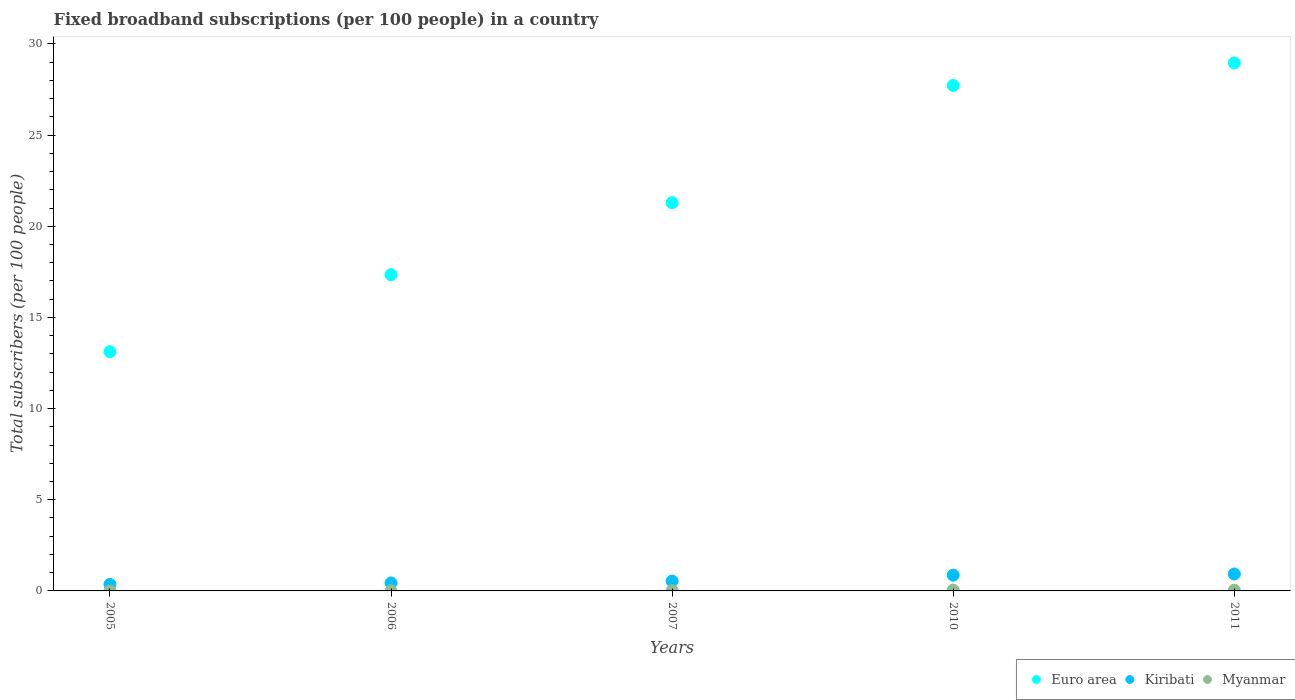How many different coloured dotlines are there?
Offer a terse response. 3. Is the number of dotlines equal to the number of legend labels?
Provide a succinct answer. Yes. What is the number of broadband subscriptions in Euro area in 2010?
Ensure brevity in your answer.  27.72. Across all years, what is the maximum number of broadband subscriptions in Kiribati?
Offer a very short reply. 0.93. Across all years, what is the minimum number of broadband subscriptions in Euro area?
Your answer should be very brief. 13.12. In which year was the number of broadband subscriptions in Kiribati minimum?
Keep it short and to the point. 2005. What is the total number of broadband subscriptions in Euro area in the graph?
Make the answer very short. 108.43. What is the difference between the number of broadband subscriptions in Myanmar in 2005 and that in 2006?
Your response must be concise. -0.01. What is the difference between the number of broadband subscriptions in Kiribati in 2006 and the number of broadband subscriptions in Euro area in 2005?
Provide a succinct answer. -12.68. What is the average number of broadband subscriptions in Myanmar per year?
Keep it short and to the point. 0.02. In the year 2007, what is the difference between the number of broadband subscriptions in Kiribati and number of broadband subscriptions in Euro area?
Your answer should be compact. -20.75. What is the ratio of the number of broadband subscriptions in Euro area in 2005 to that in 2007?
Make the answer very short. 0.62. Is the difference between the number of broadband subscriptions in Kiribati in 2006 and 2011 greater than the difference between the number of broadband subscriptions in Euro area in 2006 and 2011?
Your response must be concise. Yes. What is the difference between the highest and the second highest number of broadband subscriptions in Kiribati?
Make the answer very short. 0.06. What is the difference between the highest and the lowest number of broadband subscriptions in Myanmar?
Provide a short and direct response. 0.04. In how many years, is the number of broadband subscriptions in Myanmar greater than the average number of broadband subscriptions in Myanmar taken over all years?
Provide a succinct answer. 2. Is it the case that in every year, the sum of the number of broadband subscriptions in Myanmar and number of broadband subscriptions in Kiribati  is greater than the number of broadband subscriptions in Euro area?
Your response must be concise. No. Does the number of broadband subscriptions in Myanmar monotonically increase over the years?
Your response must be concise. No. Is the number of broadband subscriptions in Myanmar strictly less than the number of broadband subscriptions in Euro area over the years?
Keep it short and to the point. Yes. How many years are there in the graph?
Ensure brevity in your answer.  5. Does the graph contain any zero values?
Your answer should be compact. No. Where does the legend appear in the graph?
Offer a terse response. Bottom right. How many legend labels are there?
Provide a short and direct response. 3. How are the legend labels stacked?
Your answer should be compact. Horizontal. What is the title of the graph?
Your answer should be compact. Fixed broadband subscriptions (per 100 people) in a country. What is the label or title of the X-axis?
Your answer should be very brief. Years. What is the label or title of the Y-axis?
Give a very brief answer. Total subscribers (per 100 people). What is the Total subscribers (per 100 people) of Euro area in 2005?
Make the answer very short. 13.12. What is the Total subscribers (per 100 people) in Kiribati in 2005?
Provide a short and direct response. 0.36. What is the Total subscribers (per 100 people) of Myanmar in 2005?
Provide a succinct answer. 0. What is the Total subscribers (per 100 people) of Euro area in 2006?
Provide a succinct answer. 17.34. What is the Total subscribers (per 100 people) in Kiribati in 2006?
Make the answer very short. 0.44. What is the Total subscribers (per 100 people) in Myanmar in 2006?
Give a very brief answer. 0.01. What is the Total subscribers (per 100 people) of Euro area in 2007?
Keep it short and to the point. 21.29. What is the Total subscribers (per 100 people) of Kiribati in 2007?
Your answer should be very brief. 0.54. What is the Total subscribers (per 100 people) of Myanmar in 2007?
Give a very brief answer. 0.01. What is the Total subscribers (per 100 people) of Euro area in 2010?
Your answer should be compact. 27.72. What is the Total subscribers (per 100 people) in Kiribati in 2010?
Provide a succinct answer. 0.87. What is the Total subscribers (per 100 people) of Myanmar in 2010?
Offer a terse response. 0.04. What is the Total subscribers (per 100 people) in Euro area in 2011?
Offer a very short reply. 28.96. What is the Total subscribers (per 100 people) of Kiribati in 2011?
Provide a succinct answer. 0.93. What is the Total subscribers (per 100 people) in Myanmar in 2011?
Your answer should be very brief. 0.04. Across all years, what is the maximum Total subscribers (per 100 people) in Euro area?
Make the answer very short. 28.96. Across all years, what is the maximum Total subscribers (per 100 people) in Kiribati?
Keep it short and to the point. 0.93. Across all years, what is the maximum Total subscribers (per 100 people) in Myanmar?
Keep it short and to the point. 0.04. Across all years, what is the minimum Total subscribers (per 100 people) of Euro area?
Make the answer very short. 13.12. Across all years, what is the minimum Total subscribers (per 100 people) of Kiribati?
Keep it short and to the point. 0.36. Across all years, what is the minimum Total subscribers (per 100 people) in Myanmar?
Your answer should be very brief. 0. What is the total Total subscribers (per 100 people) of Euro area in the graph?
Offer a terse response. 108.43. What is the total Total subscribers (per 100 people) of Kiribati in the graph?
Give a very brief answer. 3.13. What is the total Total subscribers (per 100 people) of Myanmar in the graph?
Your response must be concise. 0.11. What is the difference between the Total subscribers (per 100 people) in Euro area in 2005 and that in 2006?
Provide a succinct answer. -4.22. What is the difference between the Total subscribers (per 100 people) of Kiribati in 2005 and that in 2006?
Ensure brevity in your answer.  -0.08. What is the difference between the Total subscribers (per 100 people) of Myanmar in 2005 and that in 2006?
Offer a terse response. -0.01. What is the difference between the Total subscribers (per 100 people) in Euro area in 2005 and that in 2007?
Offer a very short reply. -8.17. What is the difference between the Total subscribers (per 100 people) in Kiribati in 2005 and that in 2007?
Offer a very short reply. -0.18. What is the difference between the Total subscribers (per 100 people) of Myanmar in 2005 and that in 2007?
Keep it short and to the point. -0.01. What is the difference between the Total subscribers (per 100 people) in Euro area in 2005 and that in 2010?
Your answer should be very brief. -14.6. What is the difference between the Total subscribers (per 100 people) of Kiribati in 2005 and that in 2010?
Your response must be concise. -0.51. What is the difference between the Total subscribers (per 100 people) in Myanmar in 2005 and that in 2010?
Your answer should be compact. -0.04. What is the difference between the Total subscribers (per 100 people) of Euro area in 2005 and that in 2011?
Make the answer very short. -15.84. What is the difference between the Total subscribers (per 100 people) in Kiribati in 2005 and that in 2011?
Keep it short and to the point. -0.57. What is the difference between the Total subscribers (per 100 people) in Myanmar in 2005 and that in 2011?
Offer a very short reply. -0.04. What is the difference between the Total subscribers (per 100 people) in Euro area in 2006 and that in 2007?
Give a very brief answer. -3.95. What is the difference between the Total subscribers (per 100 people) in Kiribati in 2006 and that in 2007?
Your answer should be compact. -0.1. What is the difference between the Total subscribers (per 100 people) in Myanmar in 2006 and that in 2007?
Make the answer very short. -0. What is the difference between the Total subscribers (per 100 people) in Euro area in 2006 and that in 2010?
Ensure brevity in your answer.  -10.38. What is the difference between the Total subscribers (per 100 people) in Kiribati in 2006 and that in 2010?
Offer a terse response. -0.43. What is the difference between the Total subscribers (per 100 people) of Myanmar in 2006 and that in 2010?
Ensure brevity in your answer.  -0.04. What is the difference between the Total subscribers (per 100 people) of Euro area in 2006 and that in 2011?
Make the answer very short. -11.61. What is the difference between the Total subscribers (per 100 people) in Kiribati in 2006 and that in 2011?
Give a very brief answer. -0.49. What is the difference between the Total subscribers (per 100 people) in Myanmar in 2006 and that in 2011?
Your answer should be compact. -0.03. What is the difference between the Total subscribers (per 100 people) of Euro area in 2007 and that in 2010?
Provide a succinct answer. -6.43. What is the difference between the Total subscribers (per 100 people) of Kiribati in 2007 and that in 2010?
Offer a terse response. -0.33. What is the difference between the Total subscribers (per 100 people) of Myanmar in 2007 and that in 2010?
Your answer should be compact. -0.03. What is the difference between the Total subscribers (per 100 people) of Euro area in 2007 and that in 2011?
Provide a succinct answer. -7.67. What is the difference between the Total subscribers (per 100 people) of Kiribati in 2007 and that in 2011?
Provide a short and direct response. -0.39. What is the difference between the Total subscribers (per 100 people) in Myanmar in 2007 and that in 2011?
Give a very brief answer. -0.03. What is the difference between the Total subscribers (per 100 people) of Euro area in 2010 and that in 2011?
Give a very brief answer. -1.24. What is the difference between the Total subscribers (per 100 people) in Kiribati in 2010 and that in 2011?
Give a very brief answer. -0.06. What is the difference between the Total subscribers (per 100 people) of Myanmar in 2010 and that in 2011?
Offer a very short reply. 0. What is the difference between the Total subscribers (per 100 people) in Euro area in 2005 and the Total subscribers (per 100 people) in Kiribati in 2006?
Give a very brief answer. 12.68. What is the difference between the Total subscribers (per 100 people) of Euro area in 2005 and the Total subscribers (per 100 people) of Myanmar in 2006?
Offer a terse response. 13.11. What is the difference between the Total subscribers (per 100 people) in Kiribati in 2005 and the Total subscribers (per 100 people) in Myanmar in 2006?
Your response must be concise. 0.35. What is the difference between the Total subscribers (per 100 people) in Euro area in 2005 and the Total subscribers (per 100 people) in Kiribati in 2007?
Keep it short and to the point. 12.58. What is the difference between the Total subscribers (per 100 people) in Euro area in 2005 and the Total subscribers (per 100 people) in Myanmar in 2007?
Your answer should be very brief. 13.11. What is the difference between the Total subscribers (per 100 people) in Kiribati in 2005 and the Total subscribers (per 100 people) in Myanmar in 2007?
Provide a short and direct response. 0.34. What is the difference between the Total subscribers (per 100 people) of Euro area in 2005 and the Total subscribers (per 100 people) of Kiribati in 2010?
Provide a succinct answer. 12.25. What is the difference between the Total subscribers (per 100 people) of Euro area in 2005 and the Total subscribers (per 100 people) of Myanmar in 2010?
Offer a terse response. 13.08. What is the difference between the Total subscribers (per 100 people) in Kiribati in 2005 and the Total subscribers (per 100 people) in Myanmar in 2010?
Offer a very short reply. 0.31. What is the difference between the Total subscribers (per 100 people) of Euro area in 2005 and the Total subscribers (per 100 people) of Kiribati in 2011?
Your response must be concise. 12.19. What is the difference between the Total subscribers (per 100 people) of Euro area in 2005 and the Total subscribers (per 100 people) of Myanmar in 2011?
Offer a very short reply. 13.08. What is the difference between the Total subscribers (per 100 people) in Kiribati in 2005 and the Total subscribers (per 100 people) in Myanmar in 2011?
Provide a succinct answer. 0.31. What is the difference between the Total subscribers (per 100 people) of Euro area in 2006 and the Total subscribers (per 100 people) of Kiribati in 2007?
Give a very brief answer. 16.8. What is the difference between the Total subscribers (per 100 people) in Euro area in 2006 and the Total subscribers (per 100 people) in Myanmar in 2007?
Make the answer very short. 17.33. What is the difference between the Total subscribers (per 100 people) of Kiribati in 2006 and the Total subscribers (per 100 people) of Myanmar in 2007?
Keep it short and to the point. 0.42. What is the difference between the Total subscribers (per 100 people) in Euro area in 2006 and the Total subscribers (per 100 people) in Kiribati in 2010?
Your answer should be very brief. 16.48. What is the difference between the Total subscribers (per 100 people) in Euro area in 2006 and the Total subscribers (per 100 people) in Myanmar in 2010?
Make the answer very short. 17.3. What is the difference between the Total subscribers (per 100 people) in Kiribati in 2006 and the Total subscribers (per 100 people) in Myanmar in 2010?
Offer a very short reply. 0.39. What is the difference between the Total subscribers (per 100 people) in Euro area in 2006 and the Total subscribers (per 100 people) in Kiribati in 2011?
Make the answer very short. 16.42. What is the difference between the Total subscribers (per 100 people) in Euro area in 2006 and the Total subscribers (per 100 people) in Myanmar in 2011?
Your answer should be compact. 17.3. What is the difference between the Total subscribers (per 100 people) in Kiribati in 2006 and the Total subscribers (per 100 people) in Myanmar in 2011?
Your answer should be compact. 0.4. What is the difference between the Total subscribers (per 100 people) of Euro area in 2007 and the Total subscribers (per 100 people) of Kiribati in 2010?
Your response must be concise. 20.43. What is the difference between the Total subscribers (per 100 people) in Euro area in 2007 and the Total subscribers (per 100 people) in Myanmar in 2010?
Offer a very short reply. 21.25. What is the difference between the Total subscribers (per 100 people) in Kiribati in 2007 and the Total subscribers (per 100 people) in Myanmar in 2010?
Provide a succinct answer. 0.5. What is the difference between the Total subscribers (per 100 people) in Euro area in 2007 and the Total subscribers (per 100 people) in Kiribati in 2011?
Your response must be concise. 20.36. What is the difference between the Total subscribers (per 100 people) in Euro area in 2007 and the Total subscribers (per 100 people) in Myanmar in 2011?
Ensure brevity in your answer.  21.25. What is the difference between the Total subscribers (per 100 people) of Kiribati in 2007 and the Total subscribers (per 100 people) of Myanmar in 2011?
Give a very brief answer. 0.5. What is the difference between the Total subscribers (per 100 people) in Euro area in 2010 and the Total subscribers (per 100 people) in Kiribati in 2011?
Offer a very short reply. 26.79. What is the difference between the Total subscribers (per 100 people) in Euro area in 2010 and the Total subscribers (per 100 people) in Myanmar in 2011?
Offer a terse response. 27.68. What is the difference between the Total subscribers (per 100 people) in Kiribati in 2010 and the Total subscribers (per 100 people) in Myanmar in 2011?
Keep it short and to the point. 0.82. What is the average Total subscribers (per 100 people) of Euro area per year?
Give a very brief answer. 21.69. What is the average Total subscribers (per 100 people) of Myanmar per year?
Make the answer very short. 0.02. In the year 2005, what is the difference between the Total subscribers (per 100 people) of Euro area and Total subscribers (per 100 people) of Kiribati?
Ensure brevity in your answer.  12.76. In the year 2005, what is the difference between the Total subscribers (per 100 people) of Euro area and Total subscribers (per 100 people) of Myanmar?
Your answer should be compact. 13.12. In the year 2005, what is the difference between the Total subscribers (per 100 people) in Kiribati and Total subscribers (per 100 people) in Myanmar?
Provide a short and direct response. 0.36. In the year 2006, what is the difference between the Total subscribers (per 100 people) in Euro area and Total subscribers (per 100 people) in Kiribati?
Ensure brevity in your answer.  16.91. In the year 2006, what is the difference between the Total subscribers (per 100 people) of Euro area and Total subscribers (per 100 people) of Myanmar?
Your response must be concise. 17.34. In the year 2006, what is the difference between the Total subscribers (per 100 people) in Kiribati and Total subscribers (per 100 people) in Myanmar?
Keep it short and to the point. 0.43. In the year 2007, what is the difference between the Total subscribers (per 100 people) of Euro area and Total subscribers (per 100 people) of Kiribati?
Make the answer very short. 20.75. In the year 2007, what is the difference between the Total subscribers (per 100 people) of Euro area and Total subscribers (per 100 people) of Myanmar?
Ensure brevity in your answer.  21.28. In the year 2007, what is the difference between the Total subscribers (per 100 people) in Kiribati and Total subscribers (per 100 people) in Myanmar?
Provide a succinct answer. 0.53. In the year 2010, what is the difference between the Total subscribers (per 100 people) of Euro area and Total subscribers (per 100 people) of Kiribati?
Your answer should be very brief. 26.86. In the year 2010, what is the difference between the Total subscribers (per 100 people) of Euro area and Total subscribers (per 100 people) of Myanmar?
Your answer should be compact. 27.68. In the year 2010, what is the difference between the Total subscribers (per 100 people) in Kiribati and Total subscribers (per 100 people) in Myanmar?
Make the answer very short. 0.82. In the year 2011, what is the difference between the Total subscribers (per 100 people) in Euro area and Total subscribers (per 100 people) in Kiribati?
Keep it short and to the point. 28.03. In the year 2011, what is the difference between the Total subscribers (per 100 people) of Euro area and Total subscribers (per 100 people) of Myanmar?
Keep it short and to the point. 28.92. In the year 2011, what is the difference between the Total subscribers (per 100 people) in Kiribati and Total subscribers (per 100 people) in Myanmar?
Keep it short and to the point. 0.89. What is the ratio of the Total subscribers (per 100 people) of Euro area in 2005 to that in 2006?
Your response must be concise. 0.76. What is the ratio of the Total subscribers (per 100 people) in Kiribati in 2005 to that in 2006?
Provide a succinct answer. 0.81. What is the ratio of the Total subscribers (per 100 people) of Myanmar in 2005 to that in 2006?
Your response must be concise. 0.06. What is the ratio of the Total subscribers (per 100 people) of Euro area in 2005 to that in 2007?
Your answer should be very brief. 0.62. What is the ratio of the Total subscribers (per 100 people) in Kiribati in 2005 to that in 2007?
Ensure brevity in your answer.  0.66. What is the ratio of the Total subscribers (per 100 people) in Myanmar in 2005 to that in 2007?
Give a very brief answer. 0.04. What is the ratio of the Total subscribers (per 100 people) of Euro area in 2005 to that in 2010?
Offer a very short reply. 0.47. What is the ratio of the Total subscribers (per 100 people) in Kiribati in 2005 to that in 2010?
Your answer should be very brief. 0.41. What is the ratio of the Total subscribers (per 100 people) in Myanmar in 2005 to that in 2010?
Give a very brief answer. 0.01. What is the ratio of the Total subscribers (per 100 people) of Euro area in 2005 to that in 2011?
Offer a very short reply. 0.45. What is the ratio of the Total subscribers (per 100 people) in Kiribati in 2005 to that in 2011?
Your answer should be very brief. 0.38. What is the ratio of the Total subscribers (per 100 people) in Myanmar in 2005 to that in 2011?
Ensure brevity in your answer.  0.01. What is the ratio of the Total subscribers (per 100 people) in Euro area in 2006 to that in 2007?
Your response must be concise. 0.81. What is the ratio of the Total subscribers (per 100 people) in Kiribati in 2006 to that in 2007?
Make the answer very short. 0.81. What is the ratio of the Total subscribers (per 100 people) in Myanmar in 2006 to that in 2007?
Provide a short and direct response. 0.62. What is the ratio of the Total subscribers (per 100 people) of Euro area in 2006 to that in 2010?
Your answer should be compact. 0.63. What is the ratio of the Total subscribers (per 100 people) of Kiribati in 2006 to that in 2010?
Your answer should be compact. 0.51. What is the ratio of the Total subscribers (per 100 people) of Myanmar in 2006 to that in 2010?
Offer a terse response. 0.18. What is the ratio of the Total subscribers (per 100 people) in Euro area in 2006 to that in 2011?
Your answer should be compact. 0.6. What is the ratio of the Total subscribers (per 100 people) of Kiribati in 2006 to that in 2011?
Ensure brevity in your answer.  0.47. What is the ratio of the Total subscribers (per 100 people) in Myanmar in 2006 to that in 2011?
Give a very brief answer. 0.19. What is the ratio of the Total subscribers (per 100 people) of Euro area in 2007 to that in 2010?
Keep it short and to the point. 0.77. What is the ratio of the Total subscribers (per 100 people) of Kiribati in 2007 to that in 2010?
Offer a terse response. 0.62. What is the ratio of the Total subscribers (per 100 people) of Myanmar in 2007 to that in 2010?
Offer a terse response. 0.29. What is the ratio of the Total subscribers (per 100 people) in Euro area in 2007 to that in 2011?
Provide a succinct answer. 0.74. What is the ratio of the Total subscribers (per 100 people) in Kiribati in 2007 to that in 2011?
Keep it short and to the point. 0.58. What is the ratio of the Total subscribers (per 100 people) of Myanmar in 2007 to that in 2011?
Keep it short and to the point. 0.3. What is the ratio of the Total subscribers (per 100 people) of Euro area in 2010 to that in 2011?
Make the answer very short. 0.96. What is the ratio of the Total subscribers (per 100 people) of Kiribati in 2010 to that in 2011?
Give a very brief answer. 0.93. What is the ratio of the Total subscribers (per 100 people) of Myanmar in 2010 to that in 2011?
Provide a succinct answer. 1.06. What is the difference between the highest and the second highest Total subscribers (per 100 people) of Euro area?
Give a very brief answer. 1.24. What is the difference between the highest and the second highest Total subscribers (per 100 people) in Kiribati?
Offer a very short reply. 0.06. What is the difference between the highest and the second highest Total subscribers (per 100 people) in Myanmar?
Ensure brevity in your answer.  0. What is the difference between the highest and the lowest Total subscribers (per 100 people) in Euro area?
Provide a short and direct response. 15.84. What is the difference between the highest and the lowest Total subscribers (per 100 people) of Kiribati?
Offer a very short reply. 0.57. What is the difference between the highest and the lowest Total subscribers (per 100 people) of Myanmar?
Ensure brevity in your answer.  0.04. 